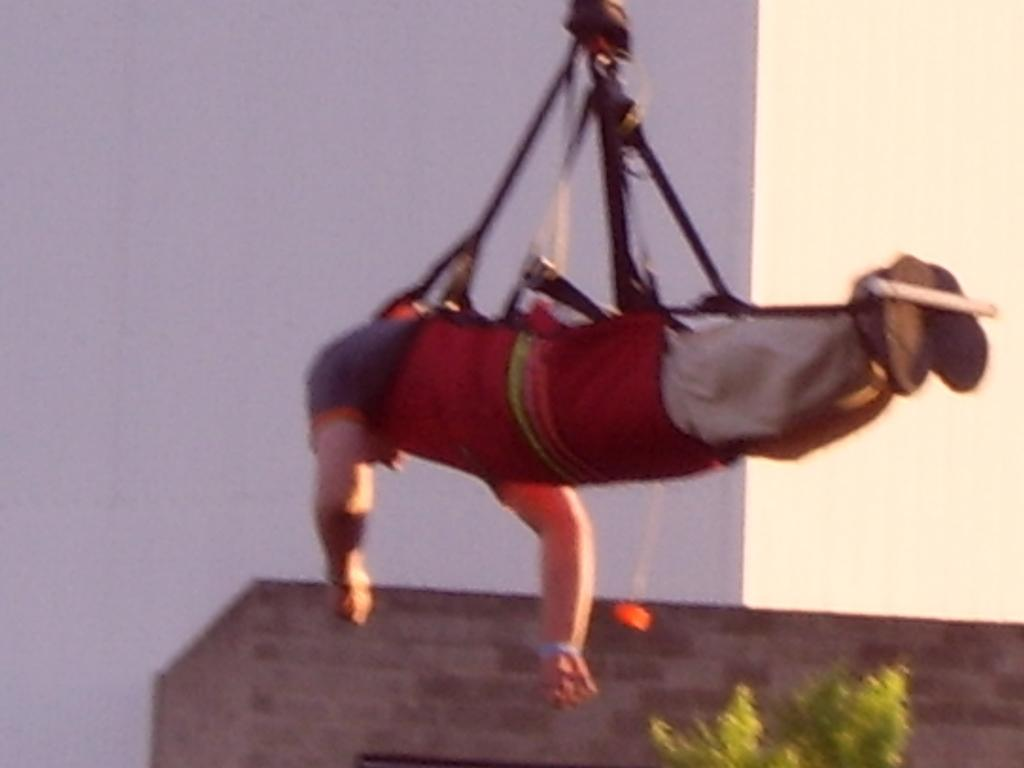What is the person in the image doing? The person in the image is in the air, tied with ropes. What can be seen in the background of the image? There is a wall visible in the image. Are there any plants in the image? Yes, there is a plant in the image. What type of destruction can be seen happening to the plant in the image? There is no destruction happening to the plant in the image; it appears to be healthy and intact. 